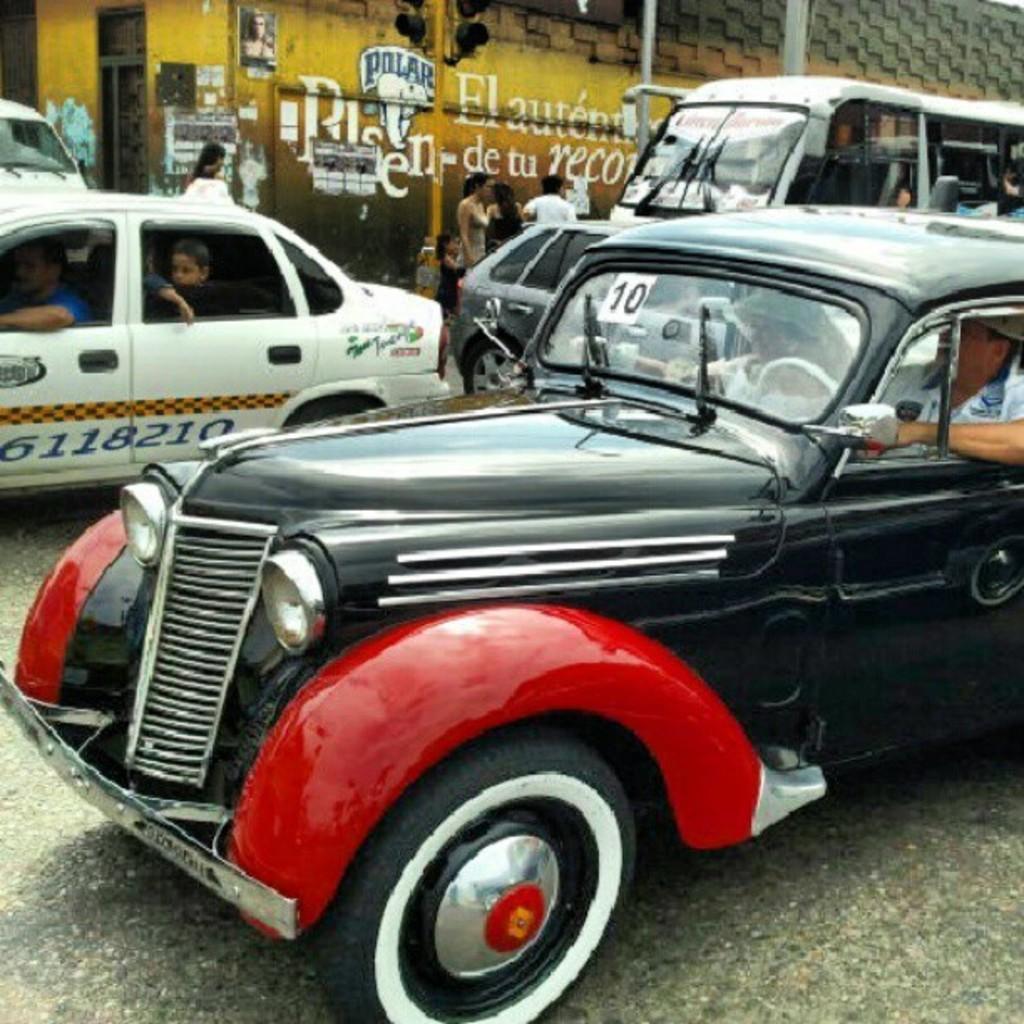In one or two sentences, can you explain what this image depicts? This is completely an outdoor picture. Here we can see a road and there are so many vehicles on the road and their persons also sitting in vehicles. We can see a wall here and there are few persons standing near to the wall. This is a traffic signal. 